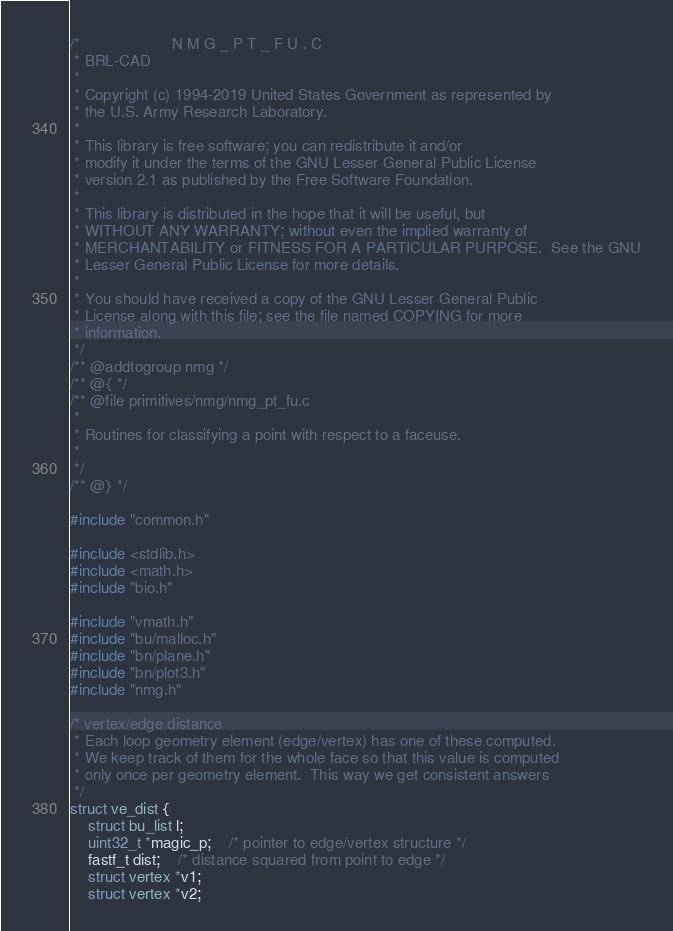<code> <loc_0><loc_0><loc_500><loc_500><_C_>/*                     N M G _ P T _ F U . C
 * BRL-CAD
 *
 * Copyright (c) 1994-2019 United States Government as represented by
 * the U.S. Army Research Laboratory.
 *
 * This library is free software; you can redistribute it and/or
 * modify it under the terms of the GNU Lesser General Public License
 * version 2.1 as published by the Free Software Foundation.
 *
 * This library is distributed in the hope that it will be useful, but
 * WITHOUT ANY WARRANTY; without even the implied warranty of
 * MERCHANTABILITY or FITNESS FOR A PARTICULAR PURPOSE.  See the GNU
 * Lesser General Public License for more details.
 *
 * You should have received a copy of the GNU Lesser General Public
 * License along with this file; see the file named COPYING for more
 * information.
 */
/** @addtogroup nmg */
/** @{ */
/** @file primitives/nmg/nmg_pt_fu.c
 *
 * Routines for classifying a point with respect to a faceuse.
 *
 */
/** @} */

#include "common.h"

#include <stdlib.h>
#include <math.h>
#include "bio.h"

#include "vmath.h"
#include "bu/malloc.h"
#include "bn/plane.h"
#include "bn/plot3.h"
#include "nmg.h"

/* vertex/edge distance
 * Each loop geometry element (edge/vertex) has one of these computed.
 * We keep track of them for the whole face so that this value is computed
 * only once per geometry element.  This way we get consistent answers
 */
struct ve_dist {
    struct bu_list l;
    uint32_t *magic_p;	/* pointer to edge/vertex structure */
    fastf_t dist;	/* distance squared from point to edge */
    struct vertex *v1;
    struct vertex *v2;</code> 